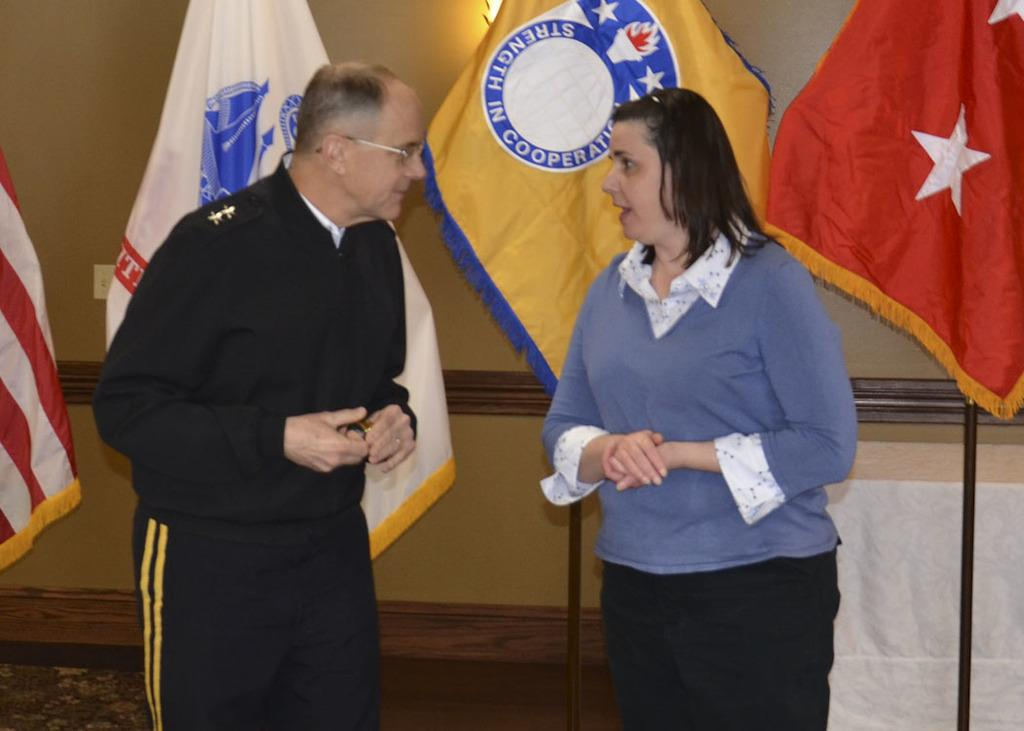How many people are present in the image? There are two people in the image. What can be observed about the clothing of the people in the image? The people are wearing different color dresses. What can be seen in the background of the image? There are colorful flags and a wall visible in the background. What type of discussion is taking place between the people in the image? There is no indication of a discussion taking place in the image. Can you tell me which side of the wall the people are standing on? The image does not provide enough information to determine which side of the wall the people are standing on. 